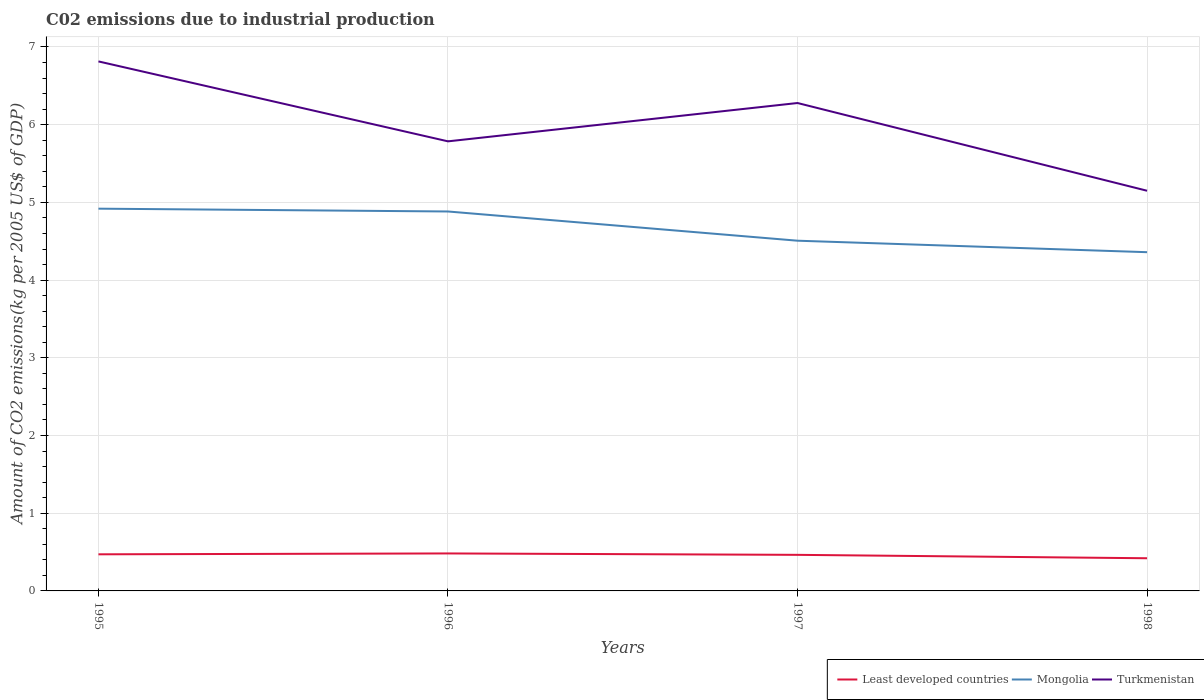Is the number of lines equal to the number of legend labels?
Provide a succinct answer. Yes. Across all years, what is the maximum amount of CO2 emitted due to industrial production in Least developed countries?
Your answer should be very brief. 0.42. What is the total amount of CO2 emitted due to industrial production in Turkmenistan in the graph?
Offer a terse response. -0.49. What is the difference between the highest and the second highest amount of CO2 emitted due to industrial production in Least developed countries?
Keep it short and to the point. 0.06. How many lines are there?
Your response must be concise. 3. How many years are there in the graph?
Your answer should be very brief. 4. Are the values on the major ticks of Y-axis written in scientific E-notation?
Give a very brief answer. No. Where does the legend appear in the graph?
Ensure brevity in your answer.  Bottom right. How many legend labels are there?
Provide a succinct answer. 3. What is the title of the graph?
Provide a short and direct response. C02 emissions due to industrial production. Does "East Asia (all income levels)" appear as one of the legend labels in the graph?
Your answer should be very brief. No. What is the label or title of the Y-axis?
Give a very brief answer. Amount of CO2 emissions(kg per 2005 US$ of GDP). What is the Amount of CO2 emissions(kg per 2005 US$ of GDP) in Least developed countries in 1995?
Offer a very short reply. 0.47. What is the Amount of CO2 emissions(kg per 2005 US$ of GDP) in Mongolia in 1995?
Make the answer very short. 4.92. What is the Amount of CO2 emissions(kg per 2005 US$ of GDP) of Turkmenistan in 1995?
Your response must be concise. 6.81. What is the Amount of CO2 emissions(kg per 2005 US$ of GDP) of Least developed countries in 1996?
Your answer should be compact. 0.48. What is the Amount of CO2 emissions(kg per 2005 US$ of GDP) of Mongolia in 1996?
Your answer should be very brief. 4.88. What is the Amount of CO2 emissions(kg per 2005 US$ of GDP) of Turkmenistan in 1996?
Give a very brief answer. 5.79. What is the Amount of CO2 emissions(kg per 2005 US$ of GDP) of Least developed countries in 1997?
Offer a very short reply. 0.46. What is the Amount of CO2 emissions(kg per 2005 US$ of GDP) of Mongolia in 1997?
Give a very brief answer. 4.51. What is the Amount of CO2 emissions(kg per 2005 US$ of GDP) of Turkmenistan in 1997?
Give a very brief answer. 6.28. What is the Amount of CO2 emissions(kg per 2005 US$ of GDP) of Least developed countries in 1998?
Ensure brevity in your answer.  0.42. What is the Amount of CO2 emissions(kg per 2005 US$ of GDP) of Mongolia in 1998?
Provide a succinct answer. 4.36. What is the Amount of CO2 emissions(kg per 2005 US$ of GDP) of Turkmenistan in 1998?
Ensure brevity in your answer.  5.15. Across all years, what is the maximum Amount of CO2 emissions(kg per 2005 US$ of GDP) in Least developed countries?
Make the answer very short. 0.48. Across all years, what is the maximum Amount of CO2 emissions(kg per 2005 US$ of GDP) in Mongolia?
Provide a short and direct response. 4.92. Across all years, what is the maximum Amount of CO2 emissions(kg per 2005 US$ of GDP) in Turkmenistan?
Provide a succinct answer. 6.81. Across all years, what is the minimum Amount of CO2 emissions(kg per 2005 US$ of GDP) of Least developed countries?
Give a very brief answer. 0.42. Across all years, what is the minimum Amount of CO2 emissions(kg per 2005 US$ of GDP) in Mongolia?
Give a very brief answer. 4.36. Across all years, what is the minimum Amount of CO2 emissions(kg per 2005 US$ of GDP) in Turkmenistan?
Offer a terse response. 5.15. What is the total Amount of CO2 emissions(kg per 2005 US$ of GDP) in Least developed countries in the graph?
Your response must be concise. 1.84. What is the total Amount of CO2 emissions(kg per 2005 US$ of GDP) in Mongolia in the graph?
Provide a short and direct response. 18.67. What is the total Amount of CO2 emissions(kg per 2005 US$ of GDP) in Turkmenistan in the graph?
Offer a terse response. 24.03. What is the difference between the Amount of CO2 emissions(kg per 2005 US$ of GDP) in Least developed countries in 1995 and that in 1996?
Ensure brevity in your answer.  -0.01. What is the difference between the Amount of CO2 emissions(kg per 2005 US$ of GDP) of Mongolia in 1995 and that in 1996?
Provide a succinct answer. 0.04. What is the difference between the Amount of CO2 emissions(kg per 2005 US$ of GDP) in Turkmenistan in 1995 and that in 1996?
Make the answer very short. 1.03. What is the difference between the Amount of CO2 emissions(kg per 2005 US$ of GDP) of Least developed countries in 1995 and that in 1997?
Make the answer very short. 0.01. What is the difference between the Amount of CO2 emissions(kg per 2005 US$ of GDP) of Mongolia in 1995 and that in 1997?
Make the answer very short. 0.41. What is the difference between the Amount of CO2 emissions(kg per 2005 US$ of GDP) in Turkmenistan in 1995 and that in 1997?
Your answer should be compact. 0.54. What is the difference between the Amount of CO2 emissions(kg per 2005 US$ of GDP) of Least developed countries in 1995 and that in 1998?
Ensure brevity in your answer.  0.05. What is the difference between the Amount of CO2 emissions(kg per 2005 US$ of GDP) of Mongolia in 1995 and that in 1998?
Your answer should be compact. 0.56. What is the difference between the Amount of CO2 emissions(kg per 2005 US$ of GDP) of Turkmenistan in 1995 and that in 1998?
Ensure brevity in your answer.  1.66. What is the difference between the Amount of CO2 emissions(kg per 2005 US$ of GDP) in Least developed countries in 1996 and that in 1997?
Provide a succinct answer. 0.02. What is the difference between the Amount of CO2 emissions(kg per 2005 US$ of GDP) in Mongolia in 1996 and that in 1997?
Provide a succinct answer. 0.38. What is the difference between the Amount of CO2 emissions(kg per 2005 US$ of GDP) in Turkmenistan in 1996 and that in 1997?
Provide a succinct answer. -0.49. What is the difference between the Amount of CO2 emissions(kg per 2005 US$ of GDP) of Least developed countries in 1996 and that in 1998?
Make the answer very short. 0.06. What is the difference between the Amount of CO2 emissions(kg per 2005 US$ of GDP) of Mongolia in 1996 and that in 1998?
Make the answer very short. 0.52. What is the difference between the Amount of CO2 emissions(kg per 2005 US$ of GDP) in Turkmenistan in 1996 and that in 1998?
Keep it short and to the point. 0.64. What is the difference between the Amount of CO2 emissions(kg per 2005 US$ of GDP) in Least developed countries in 1997 and that in 1998?
Your answer should be compact. 0.04. What is the difference between the Amount of CO2 emissions(kg per 2005 US$ of GDP) of Mongolia in 1997 and that in 1998?
Ensure brevity in your answer.  0.15. What is the difference between the Amount of CO2 emissions(kg per 2005 US$ of GDP) in Turkmenistan in 1997 and that in 1998?
Offer a terse response. 1.13. What is the difference between the Amount of CO2 emissions(kg per 2005 US$ of GDP) of Least developed countries in 1995 and the Amount of CO2 emissions(kg per 2005 US$ of GDP) of Mongolia in 1996?
Your answer should be compact. -4.41. What is the difference between the Amount of CO2 emissions(kg per 2005 US$ of GDP) in Least developed countries in 1995 and the Amount of CO2 emissions(kg per 2005 US$ of GDP) in Turkmenistan in 1996?
Give a very brief answer. -5.31. What is the difference between the Amount of CO2 emissions(kg per 2005 US$ of GDP) in Mongolia in 1995 and the Amount of CO2 emissions(kg per 2005 US$ of GDP) in Turkmenistan in 1996?
Your answer should be very brief. -0.87. What is the difference between the Amount of CO2 emissions(kg per 2005 US$ of GDP) in Least developed countries in 1995 and the Amount of CO2 emissions(kg per 2005 US$ of GDP) in Mongolia in 1997?
Offer a terse response. -4.04. What is the difference between the Amount of CO2 emissions(kg per 2005 US$ of GDP) of Least developed countries in 1995 and the Amount of CO2 emissions(kg per 2005 US$ of GDP) of Turkmenistan in 1997?
Offer a terse response. -5.81. What is the difference between the Amount of CO2 emissions(kg per 2005 US$ of GDP) of Mongolia in 1995 and the Amount of CO2 emissions(kg per 2005 US$ of GDP) of Turkmenistan in 1997?
Offer a terse response. -1.36. What is the difference between the Amount of CO2 emissions(kg per 2005 US$ of GDP) in Least developed countries in 1995 and the Amount of CO2 emissions(kg per 2005 US$ of GDP) in Mongolia in 1998?
Your response must be concise. -3.89. What is the difference between the Amount of CO2 emissions(kg per 2005 US$ of GDP) of Least developed countries in 1995 and the Amount of CO2 emissions(kg per 2005 US$ of GDP) of Turkmenistan in 1998?
Offer a terse response. -4.68. What is the difference between the Amount of CO2 emissions(kg per 2005 US$ of GDP) of Mongolia in 1995 and the Amount of CO2 emissions(kg per 2005 US$ of GDP) of Turkmenistan in 1998?
Your answer should be very brief. -0.23. What is the difference between the Amount of CO2 emissions(kg per 2005 US$ of GDP) in Least developed countries in 1996 and the Amount of CO2 emissions(kg per 2005 US$ of GDP) in Mongolia in 1997?
Give a very brief answer. -4.02. What is the difference between the Amount of CO2 emissions(kg per 2005 US$ of GDP) in Least developed countries in 1996 and the Amount of CO2 emissions(kg per 2005 US$ of GDP) in Turkmenistan in 1997?
Make the answer very short. -5.8. What is the difference between the Amount of CO2 emissions(kg per 2005 US$ of GDP) in Mongolia in 1996 and the Amount of CO2 emissions(kg per 2005 US$ of GDP) in Turkmenistan in 1997?
Your answer should be compact. -1.4. What is the difference between the Amount of CO2 emissions(kg per 2005 US$ of GDP) in Least developed countries in 1996 and the Amount of CO2 emissions(kg per 2005 US$ of GDP) in Mongolia in 1998?
Ensure brevity in your answer.  -3.88. What is the difference between the Amount of CO2 emissions(kg per 2005 US$ of GDP) of Least developed countries in 1996 and the Amount of CO2 emissions(kg per 2005 US$ of GDP) of Turkmenistan in 1998?
Your response must be concise. -4.67. What is the difference between the Amount of CO2 emissions(kg per 2005 US$ of GDP) in Mongolia in 1996 and the Amount of CO2 emissions(kg per 2005 US$ of GDP) in Turkmenistan in 1998?
Provide a succinct answer. -0.27. What is the difference between the Amount of CO2 emissions(kg per 2005 US$ of GDP) of Least developed countries in 1997 and the Amount of CO2 emissions(kg per 2005 US$ of GDP) of Mongolia in 1998?
Provide a short and direct response. -3.9. What is the difference between the Amount of CO2 emissions(kg per 2005 US$ of GDP) in Least developed countries in 1997 and the Amount of CO2 emissions(kg per 2005 US$ of GDP) in Turkmenistan in 1998?
Give a very brief answer. -4.69. What is the difference between the Amount of CO2 emissions(kg per 2005 US$ of GDP) of Mongolia in 1997 and the Amount of CO2 emissions(kg per 2005 US$ of GDP) of Turkmenistan in 1998?
Your answer should be very brief. -0.64. What is the average Amount of CO2 emissions(kg per 2005 US$ of GDP) in Least developed countries per year?
Ensure brevity in your answer.  0.46. What is the average Amount of CO2 emissions(kg per 2005 US$ of GDP) of Mongolia per year?
Keep it short and to the point. 4.67. What is the average Amount of CO2 emissions(kg per 2005 US$ of GDP) of Turkmenistan per year?
Your answer should be compact. 6.01. In the year 1995, what is the difference between the Amount of CO2 emissions(kg per 2005 US$ of GDP) in Least developed countries and Amount of CO2 emissions(kg per 2005 US$ of GDP) in Mongolia?
Provide a succinct answer. -4.45. In the year 1995, what is the difference between the Amount of CO2 emissions(kg per 2005 US$ of GDP) of Least developed countries and Amount of CO2 emissions(kg per 2005 US$ of GDP) of Turkmenistan?
Your answer should be very brief. -6.34. In the year 1995, what is the difference between the Amount of CO2 emissions(kg per 2005 US$ of GDP) in Mongolia and Amount of CO2 emissions(kg per 2005 US$ of GDP) in Turkmenistan?
Your response must be concise. -1.9. In the year 1996, what is the difference between the Amount of CO2 emissions(kg per 2005 US$ of GDP) of Least developed countries and Amount of CO2 emissions(kg per 2005 US$ of GDP) of Mongolia?
Offer a terse response. -4.4. In the year 1996, what is the difference between the Amount of CO2 emissions(kg per 2005 US$ of GDP) in Least developed countries and Amount of CO2 emissions(kg per 2005 US$ of GDP) in Turkmenistan?
Provide a succinct answer. -5.3. In the year 1996, what is the difference between the Amount of CO2 emissions(kg per 2005 US$ of GDP) of Mongolia and Amount of CO2 emissions(kg per 2005 US$ of GDP) of Turkmenistan?
Keep it short and to the point. -0.9. In the year 1997, what is the difference between the Amount of CO2 emissions(kg per 2005 US$ of GDP) of Least developed countries and Amount of CO2 emissions(kg per 2005 US$ of GDP) of Mongolia?
Provide a short and direct response. -4.04. In the year 1997, what is the difference between the Amount of CO2 emissions(kg per 2005 US$ of GDP) of Least developed countries and Amount of CO2 emissions(kg per 2005 US$ of GDP) of Turkmenistan?
Make the answer very short. -5.81. In the year 1997, what is the difference between the Amount of CO2 emissions(kg per 2005 US$ of GDP) of Mongolia and Amount of CO2 emissions(kg per 2005 US$ of GDP) of Turkmenistan?
Provide a succinct answer. -1.77. In the year 1998, what is the difference between the Amount of CO2 emissions(kg per 2005 US$ of GDP) of Least developed countries and Amount of CO2 emissions(kg per 2005 US$ of GDP) of Mongolia?
Offer a terse response. -3.94. In the year 1998, what is the difference between the Amount of CO2 emissions(kg per 2005 US$ of GDP) in Least developed countries and Amount of CO2 emissions(kg per 2005 US$ of GDP) in Turkmenistan?
Ensure brevity in your answer.  -4.73. In the year 1998, what is the difference between the Amount of CO2 emissions(kg per 2005 US$ of GDP) of Mongolia and Amount of CO2 emissions(kg per 2005 US$ of GDP) of Turkmenistan?
Keep it short and to the point. -0.79. What is the ratio of the Amount of CO2 emissions(kg per 2005 US$ of GDP) of Least developed countries in 1995 to that in 1996?
Your answer should be very brief. 0.98. What is the ratio of the Amount of CO2 emissions(kg per 2005 US$ of GDP) in Mongolia in 1995 to that in 1996?
Provide a succinct answer. 1.01. What is the ratio of the Amount of CO2 emissions(kg per 2005 US$ of GDP) in Turkmenistan in 1995 to that in 1996?
Keep it short and to the point. 1.18. What is the ratio of the Amount of CO2 emissions(kg per 2005 US$ of GDP) of Least developed countries in 1995 to that in 1997?
Keep it short and to the point. 1.01. What is the ratio of the Amount of CO2 emissions(kg per 2005 US$ of GDP) of Mongolia in 1995 to that in 1997?
Your answer should be compact. 1.09. What is the ratio of the Amount of CO2 emissions(kg per 2005 US$ of GDP) in Turkmenistan in 1995 to that in 1997?
Provide a succinct answer. 1.09. What is the ratio of the Amount of CO2 emissions(kg per 2005 US$ of GDP) of Least developed countries in 1995 to that in 1998?
Your answer should be compact. 1.12. What is the ratio of the Amount of CO2 emissions(kg per 2005 US$ of GDP) in Mongolia in 1995 to that in 1998?
Your answer should be very brief. 1.13. What is the ratio of the Amount of CO2 emissions(kg per 2005 US$ of GDP) in Turkmenistan in 1995 to that in 1998?
Provide a succinct answer. 1.32. What is the ratio of the Amount of CO2 emissions(kg per 2005 US$ of GDP) of Least developed countries in 1996 to that in 1997?
Your answer should be compact. 1.04. What is the ratio of the Amount of CO2 emissions(kg per 2005 US$ of GDP) in Mongolia in 1996 to that in 1997?
Give a very brief answer. 1.08. What is the ratio of the Amount of CO2 emissions(kg per 2005 US$ of GDP) of Turkmenistan in 1996 to that in 1997?
Offer a very short reply. 0.92. What is the ratio of the Amount of CO2 emissions(kg per 2005 US$ of GDP) in Least developed countries in 1996 to that in 1998?
Offer a terse response. 1.15. What is the ratio of the Amount of CO2 emissions(kg per 2005 US$ of GDP) of Mongolia in 1996 to that in 1998?
Keep it short and to the point. 1.12. What is the ratio of the Amount of CO2 emissions(kg per 2005 US$ of GDP) of Turkmenistan in 1996 to that in 1998?
Ensure brevity in your answer.  1.12. What is the ratio of the Amount of CO2 emissions(kg per 2005 US$ of GDP) of Least developed countries in 1997 to that in 1998?
Give a very brief answer. 1.1. What is the ratio of the Amount of CO2 emissions(kg per 2005 US$ of GDP) in Mongolia in 1997 to that in 1998?
Provide a succinct answer. 1.03. What is the ratio of the Amount of CO2 emissions(kg per 2005 US$ of GDP) of Turkmenistan in 1997 to that in 1998?
Offer a very short reply. 1.22. What is the difference between the highest and the second highest Amount of CO2 emissions(kg per 2005 US$ of GDP) of Least developed countries?
Offer a very short reply. 0.01. What is the difference between the highest and the second highest Amount of CO2 emissions(kg per 2005 US$ of GDP) in Mongolia?
Keep it short and to the point. 0.04. What is the difference between the highest and the second highest Amount of CO2 emissions(kg per 2005 US$ of GDP) of Turkmenistan?
Offer a very short reply. 0.54. What is the difference between the highest and the lowest Amount of CO2 emissions(kg per 2005 US$ of GDP) of Least developed countries?
Make the answer very short. 0.06. What is the difference between the highest and the lowest Amount of CO2 emissions(kg per 2005 US$ of GDP) of Mongolia?
Make the answer very short. 0.56. What is the difference between the highest and the lowest Amount of CO2 emissions(kg per 2005 US$ of GDP) in Turkmenistan?
Ensure brevity in your answer.  1.66. 